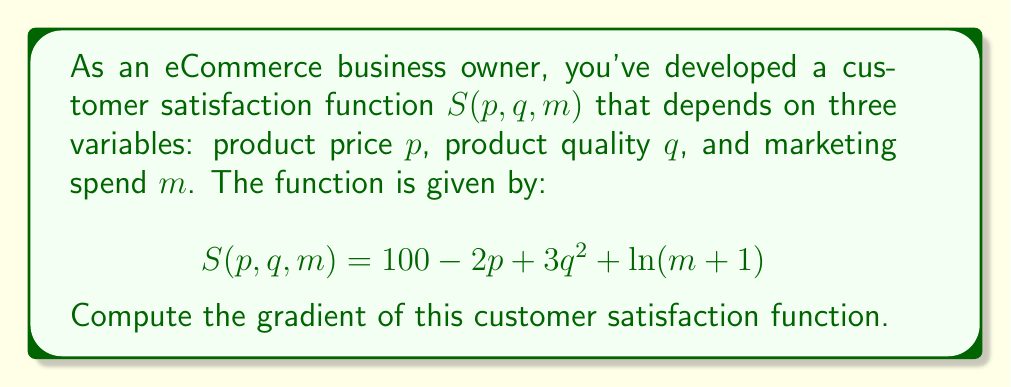Could you help me with this problem? To find the gradient of the customer satisfaction function $S(p, q, m)$, we need to calculate the partial derivatives with respect to each variable:

1. Partial derivative with respect to $p$:
   $$\frac{\partial S}{\partial p} = -2$$

2. Partial derivative with respect to $q$:
   $$\frac{\partial S}{\partial q} = 6q$$

3. Partial derivative with respect to $m$:
   $$\frac{\partial S}{\partial m} = \frac{1}{m+1}$$

The gradient is a vector containing these partial derivatives:

$$\nabla S(p, q, m) = \left(\frac{\partial S}{\partial p}, \frac{\partial S}{\partial q}, \frac{\partial S}{\partial m}\right)$$

Substituting the calculated partial derivatives:

$$\nabla S(p, q, m) = \left(-2, 6q, \frac{1}{m+1}\right)$$

This gradient vector indicates how the customer satisfaction changes with respect to each variable. A positive component suggests that increasing that variable will increase satisfaction, while a negative component suggests the opposite.
Answer: $$\nabla S(p, q, m) = \left(-2, 6q, \frac{1}{m+1}\right)$$ 